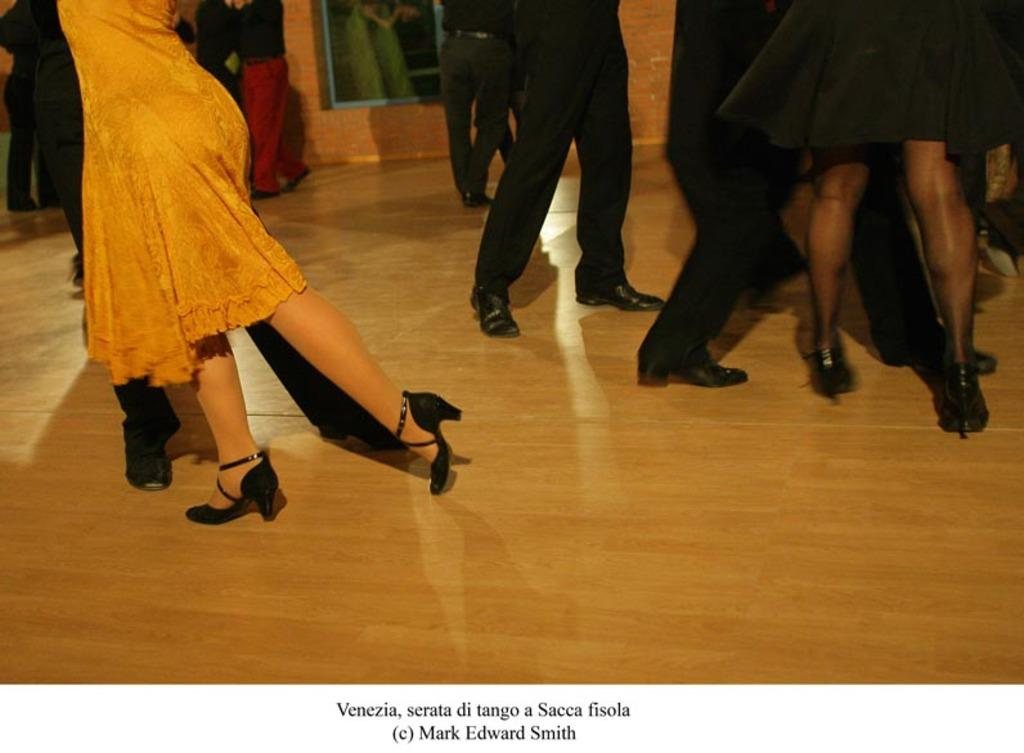What can be seen in the image? There are people standing in the image. Where are the people standing? The people are standing on the floor. What is visible in the background of the image? There is a wall visible in the background of the image. What information is provided at the bottom of the image? There is text written at the bottom of the image. How many spiders are crawling on the wall in the image? There are no spiders visible in the image; only people, the floor, and a wall are present. 